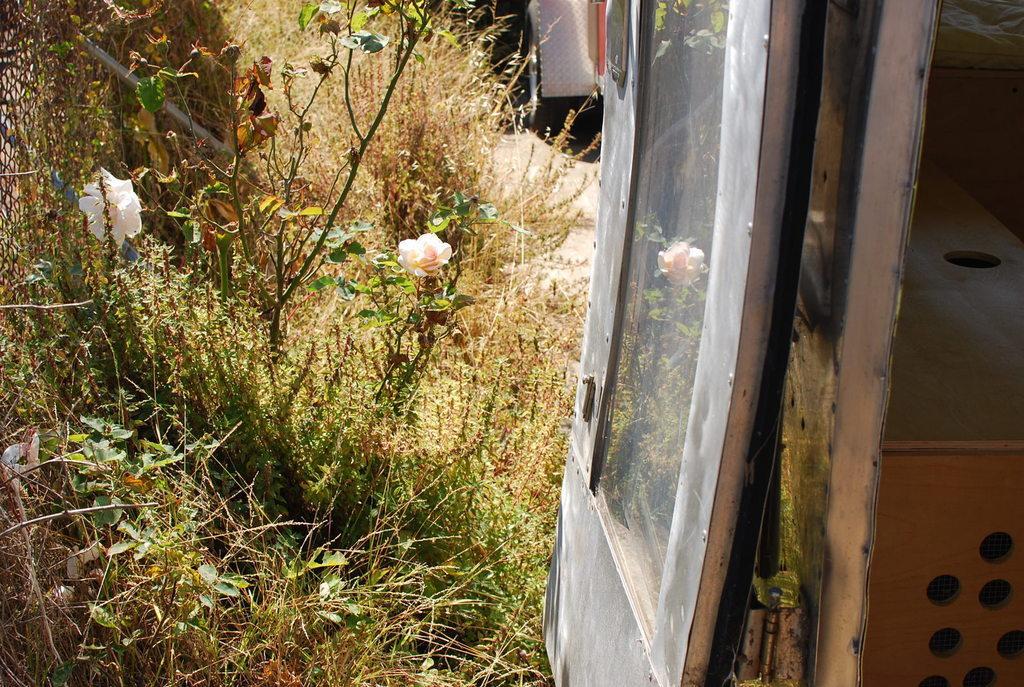Could you give a brief overview of what you see in this image? In this picture I can see a vehicle, bed, door, plants, flowers and some other objects. 